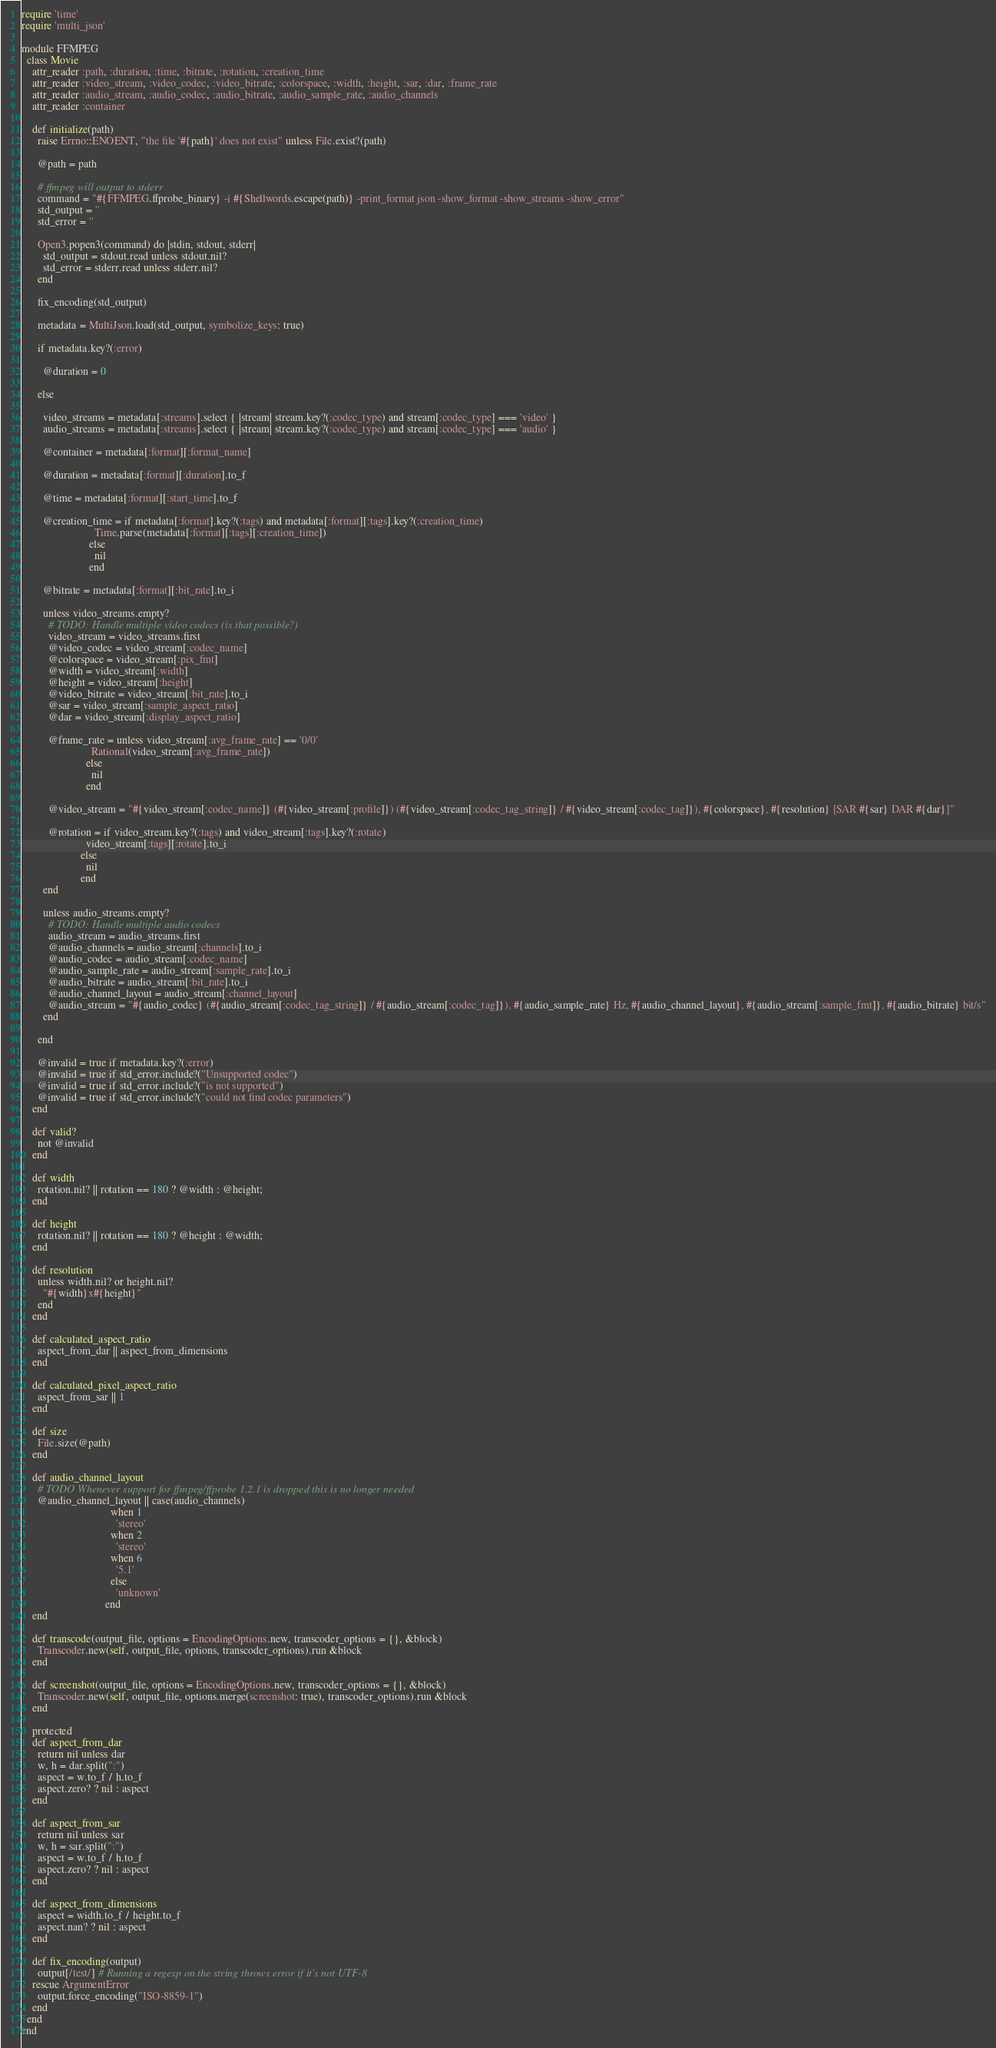Convert code to text. <code><loc_0><loc_0><loc_500><loc_500><_Ruby_>require 'time'
require 'multi_json'

module FFMPEG
  class Movie
    attr_reader :path, :duration, :time, :bitrate, :rotation, :creation_time
    attr_reader :video_stream, :video_codec, :video_bitrate, :colorspace, :width, :height, :sar, :dar, :frame_rate
    attr_reader :audio_stream, :audio_codec, :audio_bitrate, :audio_sample_rate, :audio_channels
    attr_reader :container

    def initialize(path)
      raise Errno::ENOENT, "the file '#{path}' does not exist" unless File.exist?(path)

      @path = path

      # ffmpeg will output to stderr
      command = "#{FFMPEG.ffprobe_binary} -i #{Shellwords.escape(path)} -print_format json -show_format -show_streams -show_error"
      std_output = ''
      std_error = ''

      Open3.popen3(command) do |stdin, stdout, stderr|
        std_output = stdout.read unless stdout.nil?
        std_error = stderr.read unless stderr.nil?
      end

      fix_encoding(std_output)

      metadata = MultiJson.load(std_output, symbolize_keys: true)

      if metadata.key?(:error)

        @duration = 0

      else

        video_streams = metadata[:streams].select { |stream| stream.key?(:codec_type) and stream[:codec_type] === 'video' }
        audio_streams = metadata[:streams].select { |stream| stream.key?(:codec_type) and stream[:codec_type] === 'audio' }

        @container = metadata[:format][:format_name]

        @duration = metadata[:format][:duration].to_f

        @time = metadata[:format][:start_time].to_f

        @creation_time = if metadata[:format].key?(:tags) and metadata[:format][:tags].key?(:creation_time)
                           Time.parse(metadata[:format][:tags][:creation_time])
                         else
                           nil
                         end

        @bitrate = metadata[:format][:bit_rate].to_i

        unless video_streams.empty?
          # TODO: Handle multiple video codecs (is that possible?)
          video_stream = video_streams.first
          @video_codec = video_stream[:codec_name]
          @colorspace = video_stream[:pix_fmt]
          @width = video_stream[:width]
          @height = video_stream[:height]
          @video_bitrate = video_stream[:bit_rate].to_i
          @sar = video_stream[:sample_aspect_ratio]
          @dar = video_stream[:display_aspect_ratio]

          @frame_rate = unless video_stream[:avg_frame_rate] == '0/0'
                          Rational(video_stream[:avg_frame_rate])
                        else
                          nil
                        end

          @video_stream = "#{video_stream[:codec_name]} (#{video_stream[:profile]}) (#{video_stream[:codec_tag_string]} / #{video_stream[:codec_tag]}), #{colorspace}, #{resolution} [SAR #{sar} DAR #{dar}]"

          @rotation = if video_stream.key?(:tags) and video_stream[:tags].key?(:rotate)
                        video_stream[:tags][:rotate].to_i
                      else
                        nil
                      end
        end

        unless audio_streams.empty?
          # TODO: Handle multiple audio codecs
          audio_stream = audio_streams.first
          @audio_channels = audio_stream[:channels].to_i
          @audio_codec = audio_stream[:codec_name]
          @audio_sample_rate = audio_stream[:sample_rate].to_i
          @audio_bitrate = audio_stream[:bit_rate].to_i
          @audio_channel_layout = audio_stream[:channel_layout]
          @audio_stream = "#{audio_codec} (#{audio_stream[:codec_tag_string]} / #{audio_stream[:codec_tag]}), #{audio_sample_rate} Hz, #{audio_channel_layout}, #{audio_stream[:sample_fmt]}, #{audio_bitrate} bit/s"
        end

      end

      @invalid = true if metadata.key?(:error)
      @invalid = true if std_error.include?("Unsupported codec")
      @invalid = true if std_error.include?("is not supported")
      @invalid = true if std_error.include?("could not find codec parameters")
    end

    def valid?
      not @invalid
    end

    def width
      rotation.nil? || rotation == 180 ? @width : @height;
    end

    def height
      rotation.nil? || rotation == 180 ? @height : @width;
    end

    def resolution
      unless width.nil? or height.nil?
        "#{width}x#{height}"
      end
    end

    def calculated_aspect_ratio
      aspect_from_dar || aspect_from_dimensions
    end

    def calculated_pixel_aspect_ratio
      aspect_from_sar || 1
    end

    def size
      File.size(@path)
    end

    def audio_channel_layout
      # TODO Whenever support for ffmpeg/ffprobe 1.2.1 is dropped this is no longer needed
      @audio_channel_layout || case(audio_channels)
                                 when 1
                                   'stereo'
                                 when 2
                                   'stereo'
                                 when 6
                                   '5.1'
                                 else
                                   'unknown'
                               end
    end

    def transcode(output_file, options = EncodingOptions.new, transcoder_options = {}, &block)
      Transcoder.new(self, output_file, options, transcoder_options).run &block
    end

    def screenshot(output_file, options = EncodingOptions.new, transcoder_options = {}, &block)
      Transcoder.new(self, output_file, options.merge(screenshot: true), transcoder_options).run &block
    end

    protected
    def aspect_from_dar
      return nil unless dar
      w, h = dar.split(":")
      aspect = w.to_f / h.to_f
      aspect.zero? ? nil : aspect
    end

    def aspect_from_sar
      return nil unless sar
      w, h = sar.split(":")
      aspect = w.to_f / h.to_f
      aspect.zero? ? nil : aspect
    end

    def aspect_from_dimensions
      aspect = width.to_f / height.to_f
      aspect.nan? ? nil : aspect
    end

    def fix_encoding(output)
      output[/test/] # Running a regexp on the string throws error if it's not UTF-8
    rescue ArgumentError
      output.force_encoding("ISO-8859-1")
    end
  end
end
</code> 